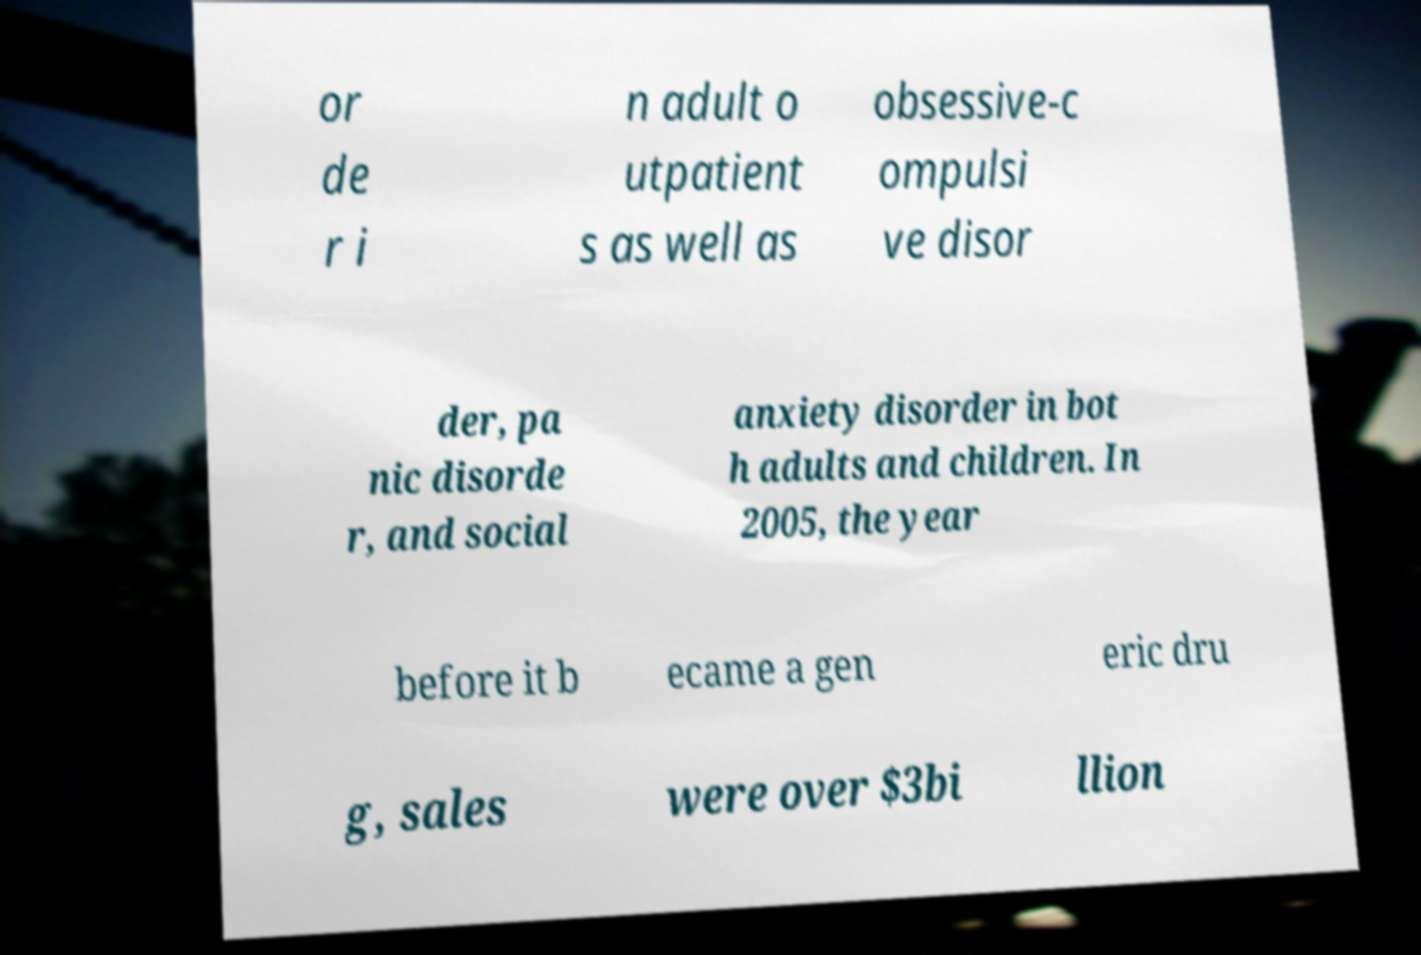Please read and relay the text visible in this image. What does it say? or de r i n adult o utpatient s as well as obsessive-c ompulsi ve disor der, pa nic disorde r, and social anxiety disorder in bot h adults and children. In 2005, the year before it b ecame a gen eric dru g, sales were over $3bi llion 